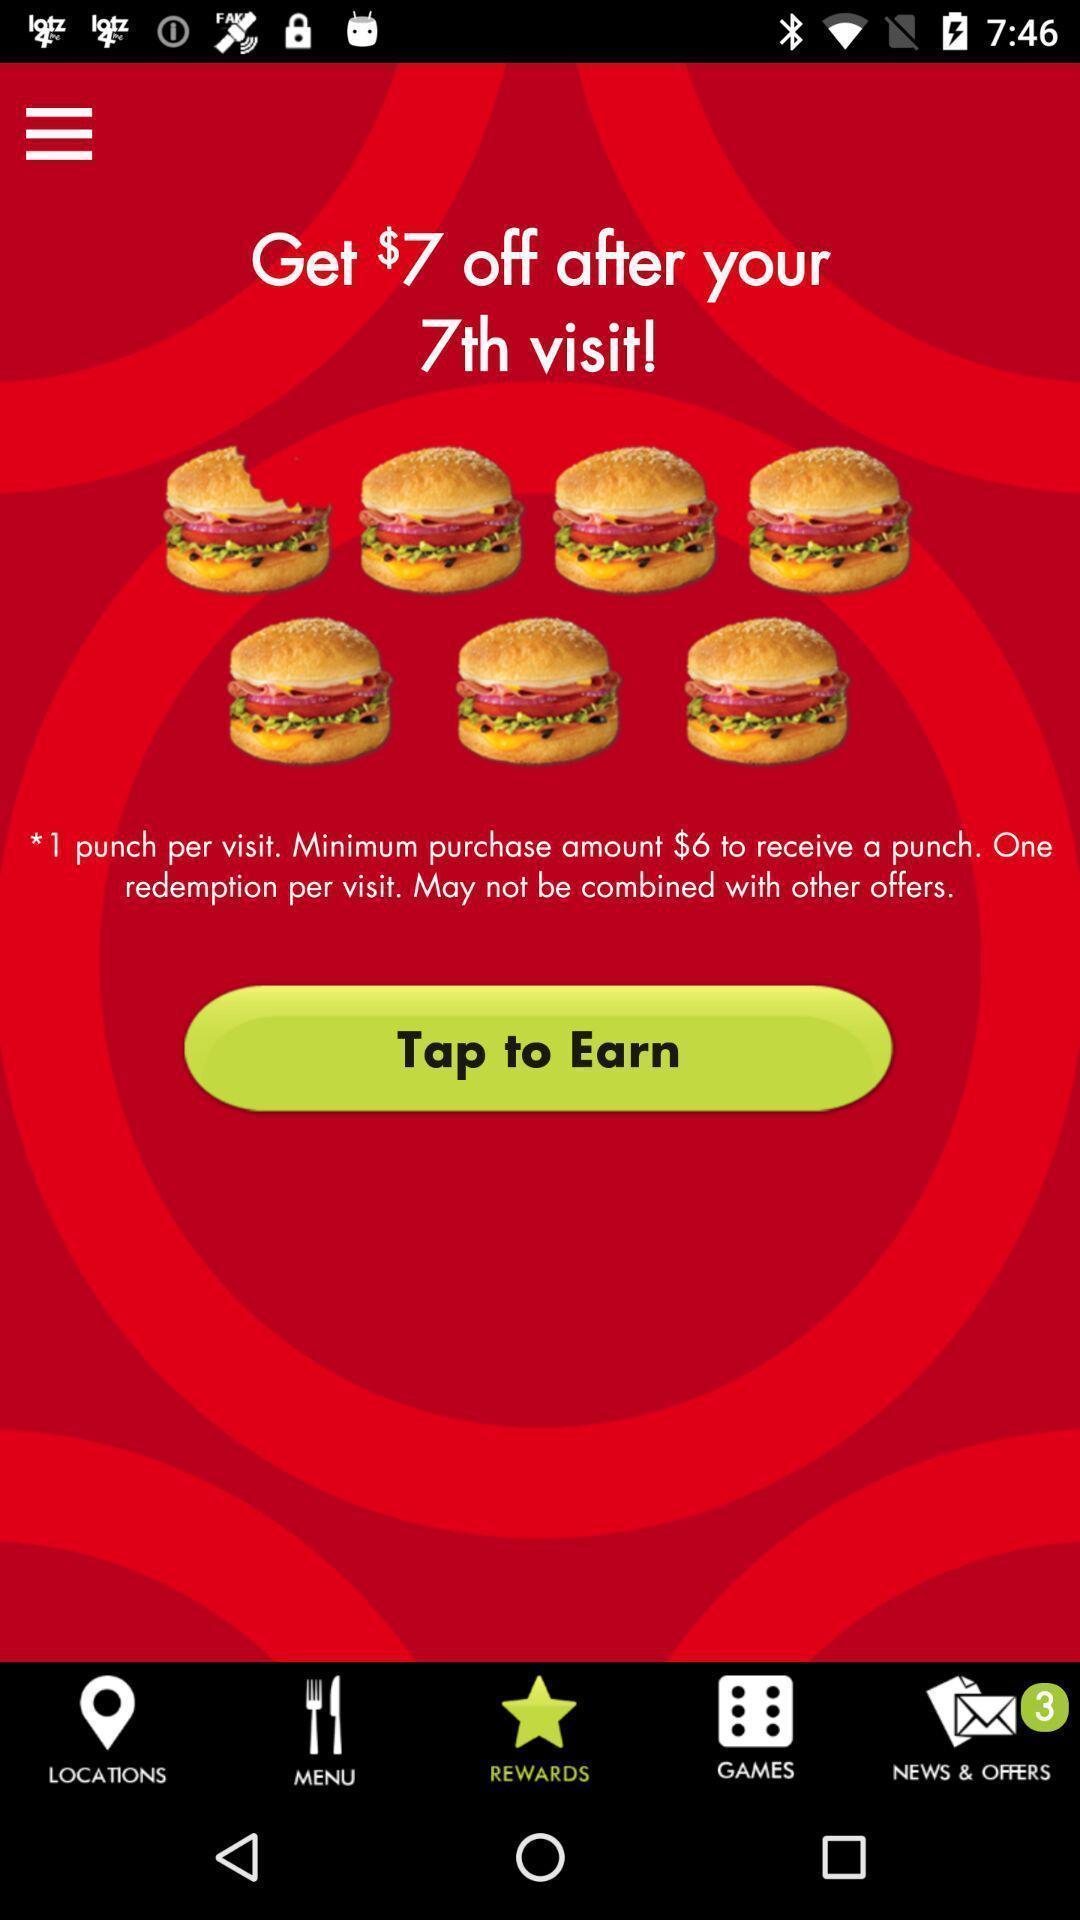Tell me what you see in this picture. Page requesting to tap to earn rewards on an app. 